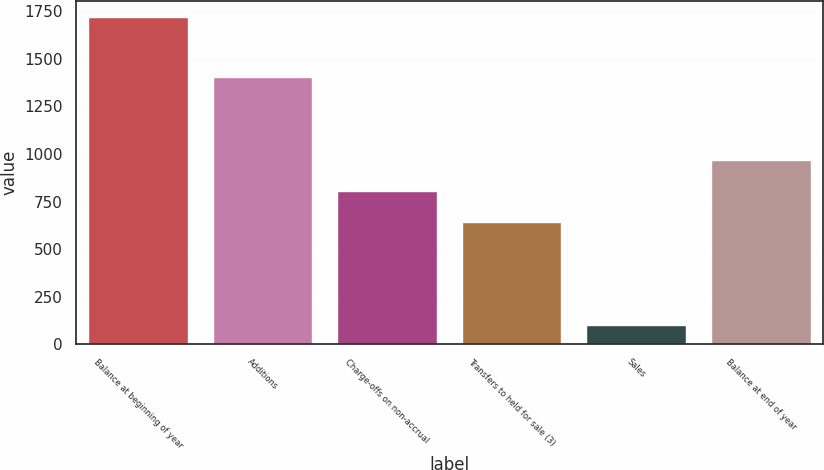Convert chart. <chart><loc_0><loc_0><loc_500><loc_500><bar_chart><fcel>Balance at beginning of year<fcel>Additions<fcel>Charge-offs on non-accrual<fcel>Transfers to held for sale (3)<fcel>Sales<fcel>Balance at end of year<nl><fcel>1717<fcel>1405<fcel>805.8<fcel>644<fcel>99<fcel>967.6<nl></chart> 